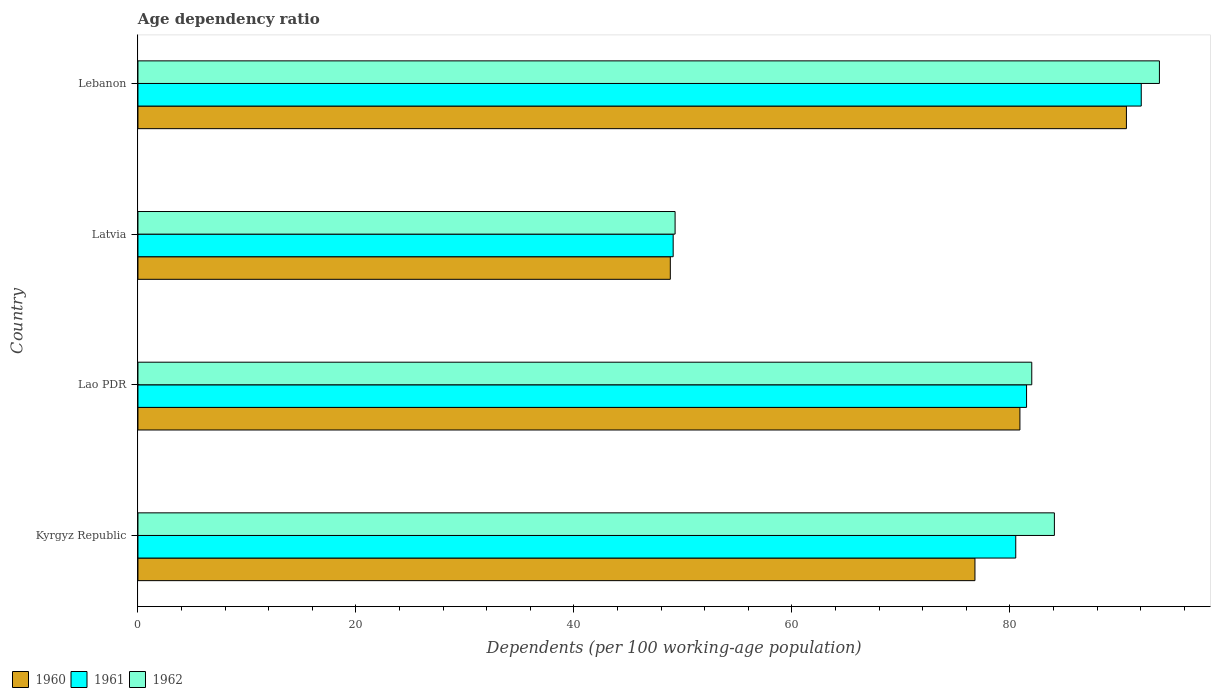How many different coloured bars are there?
Provide a succinct answer. 3. How many groups of bars are there?
Provide a succinct answer. 4. Are the number of bars per tick equal to the number of legend labels?
Your answer should be compact. Yes. Are the number of bars on each tick of the Y-axis equal?
Offer a terse response. Yes. How many bars are there on the 3rd tick from the top?
Ensure brevity in your answer.  3. How many bars are there on the 3rd tick from the bottom?
Ensure brevity in your answer.  3. What is the label of the 4th group of bars from the top?
Make the answer very short. Kyrgyz Republic. In how many cases, is the number of bars for a given country not equal to the number of legend labels?
Give a very brief answer. 0. What is the age dependency ratio in in 1962 in Lebanon?
Provide a succinct answer. 93.73. Across all countries, what is the maximum age dependency ratio in in 1962?
Keep it short and to the point. 93.73. Across all countries, what is the minimum age dependency ratio in in 1961?
Provide a short and direct response. 49.11. In which country was the age dependency ratio in in 1961 maximum?
Provide a short and direct response. Lebanon. In which country was the age dependency ratio in in 1961 minimum?
Provide a short and direct response. Latvia. What is the total age dependency ratio in in 1960 in the graph?
Keep it short and to the point. 297.27. What is the difference between the age dependency ratio in in 1960 in Kyrgyz Republic and that in Lao PDR?
Offer a terse response. -4.13. What is the difference between the age dependency ratio in in 1962 in Lebanon and the age dependency ratio in in 1960 in Kyrgyz Republic?
Offer a very short reply. 16.93. What is the average age dependency ratio in in 1962 per country?
Make the answer very short. 77.28. What is the difference between the age dependency ratio in in 1962 and age dependency ratio in in 1961 in Lao PDR?
Your response must be concise. 0.48. What is the ratio of the age dependency ratio in in 1960 in Kyrgyz Republic to that in Latvia?
Make the answer very short. 1.57. What is the difference between the highest and the second highest age dependency ratio in in 1962?
Keep it short and to the point. 9.64. What is the difference between the highest and the lowest age dependency ratio in in 1961?
Ensure brevity in your answer.  42.95. In how many countries, is the age dependency ratio in in 1960 greater than the average age dependency ratio in in 1960 taken over all countries?
Provide a succinct answer. 3. Is the sum of the age dependency ratio in in 1961 in Lao PDR and Lebanon greater than the maximum age dependency ratio in in 1962 across all countries?
Your answer should be compact. Yes. Is it the case that in every country, the sum of the age dependency ratio in in 1961 and age dependency ratio in in 1960 is greater than the age dependency ratio in in 1962?
Give a very brief answer. Yes. How many bars are there?
Your answer should be very brief. 12. How many countries are there in the graph?
Ensure brevity in your answer.  4. What is the difference between two consecutive major ticks on the X-axis?
Your response must be concise. 20. Are the values on the major ticks of X-axis written in scientific E-notation?
Your answer should be very brief. No. Does the graph contain any zero values?
Give a very brief answer. No. Does the graph contain grids?
Your response must be concise. No. What is the title of the graph?
Give a very brief answer. Age dependency ratio. What is the label or title of the X-axis?
Offer a very short reply. Dependents (per 100 working-age population). What is the Dependents (per 100 working-age population) in 1960 in Kyrgyz Republic?
Offer a terse response. 76.8. What is the Dependents (per 100 working-age population) of 1961 in Kyrgyz Republic?
Your answer should be compact. 80.54. What is the Dependents (per 100 working-age population) in 1962 in Kyrgyz Republic?
Ensure brevity in your answer.  84.09. What is the Dependents (per 100 working-age population) in 1960 in Lao PDR?
Give a very brief answer. 80.93. What is the Dependents (per 100 working-age population) of 1961 in Lao PDR?
Your answer should be very brief. 81.54. What is the Dependents (per 100 working-age population) in 1962 in Lao PDR?
Make the answer very short. 82.01. What is the Dependents (per 100 working-age population) in 1960 in Latvia?
Make the answer very short. 48.85. What is the Dependents (per 100 working-age population) in 1961 in Latvia?
Your response must be concise. 49.11. What is the Dependents (per 100 working-age population) of 1962 in Latvia?
Your answer should be very brief. 49.29. What is the Dependents (per 100 working-age population) in 1960 in Lebanon?
Make the answer very short. 90.7. What is the Dependents (per 100 working-age population) of 1961 in Lebanon?
Provide a succinct answer. 92.06. What is the Dependents (per 100 working-age population) in 1962 in Lebanon?
Your response must be concise. 93.73. Across all countries, what is the maximum Dependents (per 100 working-age population) of 1960?
Make the answer very short. 90.7. Across all countries, what is the maximum Dependents (per 100 working-age population) of 1961?
Keep it short and to the point. 92.06. Across all countries, what is the maximum Dependents (per 100 working-age population) of 1962?
Offer a terse response. 93.73. Across all countries, what is the minimum Dependents (per 100 working-age population) in 1960?
Your answer should be very brief. 48.85. Across all countries, what is the minimum Dependents (per 100 working-age population) in 1961?
Give a very brief answer. 49.11. Across all countries, what is the minimum Dependents (per 100 working-age population) of 1962?
Offer a very short reply. 49.29. What is the total Dependents (per 100 working-age population) of 1960 in the graph?
Give a very brief answer. 297.27. What is the total Dependents (per 100 working-age population) of 1961 in the graph?
Your answer should be compact. 303.25. What is the total Dependents (per 100 working-age population) of 1962 in the graph?
Offer a terse response. 309.12. What is the difference between the Dependents (per 100 working-age population) in 1960 in Kyrgyz Republic and that in Lao PDR?
Make the answer very short. -4.13. What is the difference between the Dependents (per 100 working-age population) of 1961 in Kyrgyz Republic and that in Lao PDR?
Keep it short and to the point. -0.99. What is the difference between the Dependents (per 100 working-age population) in 1962 in Kyrgyz Republic and that in Lao PDR?
Your answer should be compact. 2.08. What is the difference between the Dependents (per 100 working-age population) of 1960 in Kyrgyz Republic and that in Latvia?
Give a very brief answer. 27.95. What is the difference between the Dependents (per 100 working-age population) in 1961 in Kyrgyz Republic and that in Latvia?
Ensure brevity in your answer.  31.43. What is the difference between the Dependents (per 100 working-age population) of 1962 in Kyrgyz Republic and that in Latvia?
Ensure brevity in your answer.  34.8. What is the difference between the Dependents (per 100 working-age population) in 1960 in Kyrgyz Republic and that in Lebanon?
Ensure brevity in your answer.  -13.9. What is the difference between the Dependents (per 100 working-age population) in 1961 in Kyrgyz Republic and that in Lebanon?
Offer a terse response. -11.52. What is the difference between the Dependents (per 100 working-age population) in 1962 in Kyrgyz Republic and that in Lebanon?
Provide a short and direct response. -9.64. What is the difference between the Dependents (per 100 working-age population) in 1960 in Lao PDR and that in Latvia?
Offer a terse response. 32.08. What is the difference between the Dependents (per 100 working-age population) of 1961 in Lao PDR and that in Latvia?
Make the answer very short. 32.43. What is the difference between the Dependents (per 100 working-age population) in 1962 in Lao PDR and that in Latvia?
Provide a succinct answer. 32.73. What is the difference between the Dependents (per 100 working-age population) in 1960 in Lao PDR and that in Lebanon?
Make the answer very short. -9.77. What is the difference between the Dependents (per 100 working-age population) of 1961 in Lao PDR and that in Lebanon?
Provide a succinct answer. -10.52. What is the difference between the Dependents (per 100 working-age population) of 1962 in Lao PDR and that in Lebanon?
Ensure brevity in your answer.  -11.71. What is the difference between the Dependents (per 100 working-age population) of 1960 in Latvia and that in Lebanon?
Your response must be concise. -41.85. What is the difference between the Dependents (per 100 working-age population) of 1961 in Latvia and that in Lebanon?
Your response must be concise. -42.95. What is the difference between the Dependents (per 100 working-age population) of 1962 in Latvia and that in Lebanon?
Provide a short and direct response. -44.44. What is the difference between the Dependents (per 100 working-age population) of 1960 in Kyrgyz Republic and the Dependents (per 100 working-age population) of 1961 in Lao PDR?
Provide a short and direct response. -4.74. What is the difference between the Dependents (per 100 working-age population) of 1960 in Kyrgyz Republic and the Dependents (per 100 working-age population) of 1962 in Lao PDR?
Ensure brevity in your answer.  -5.21. What is the difference between the Dependents (per 100 working-age population) of 1961 in Kyrgyz Republic and the Dependents (per 100 working-age population) of 1962 in Lao PDR?
Ensure brevity in your answer.  -1.47. What is the difference between the Dependents (per 100 working-age population) of 1960 in Kyrgyz Republic and the Dependents (per 100 working-age population) of 1961 in Latvia?
Your answer should be compact. 27.69. What is the difference between the Dependents (per 100 working-age population) of 1960 in Kyrgyz Republic and the Dependents (per 100 working-age population) of 1962 in Latvia?
Offer a very short reply. 27.51. What is the difference between the Dependents (per 100 working-age population) in 1961 in Kyrgyz Republic and the Dependents (per 100 working-age population) in 1962 in Latvia?
Ensure brevity in your answer.  31.26. What is the difference between the Dependents (per 100 working-age population) in 1960 in Kyrgyz Republic and the Dependents (per 100 working-age population) in 1961 in Lebanon?
Your answer should be compact. -15.26. What is the difference between the Dependents (per 100 working-age population) of 1960 in Kyrgyz Republic and the Dependents (per 100 working-age population) of 1962 in Lebanon?
Keep it short and to the point. -16.93. What is the difference between the Dependents (per 100 working-age population) in 1961 in Kyrgyz Republic and the Dependents (per 100 working-age population) in 1962 in Lebanon?
Give a very brief answer. -13.18. What is the difference between the Dependents (per 100 working-age population) in 1960 in Lao PDR and the Dependents (per 100 working-age population) in 1961 in Latvia?
Your response must be concise. 31.82. What is the difference between the Dependents (per 100 working-age population) of 1960 in Lao PDR and the Dependents (per 100 working-age population) of 1962 in Latvia?
Keep it short and to the point. 31.64. What is the difference between the Dependents (per 100 working-age population) in 1961 in Lao PDR and the Dependents (per 100 working-age population) in 1962 in Latvia?
Provide a short and direct response. 32.25. What is the difference between the Dependents (per 100 working-age population) in 1960 in Lao PDR and the Dependents (per 100 working-age population) in 1961 in Lebanon?
Provide a short and direct response. -11.13. What is the difference between the Dependents (per 100 working-age population) of 1961 in Lao PDR and the Dependents (per 100 working-age population) of 1962 in Lebanon?
Offer a terse response. -12.19. What is the difference between the Dependents (per 100 working-age population) of 1960 in Latvia and the Dependents (per 100 working-age population) of 1961 in Lebanon?
Offer a terse response. -43.21. What is the difference between the Dependents (per 100 working-age population) of 1960 in Latvia and the Dependents (per 100 working-age population) of 1962 in Lebanon?
Your answer should be compact. -44.88. What is the difference between the Dependents (per 100 working-age population) of 1961 in Latvia and the Dependents (per 100 working-age population) of 1962 in Lebanon?
Give a very brief answer. -44.62. What is the average Dependents (per 100 working-age population) of 1960 per country?
Provide a succinct answer. 74.32. What is the average Dependents (per 100 working-age population) in 1961 per country?
Your answer should be compact. 75.81. What is the average Dependents (per 100 working-age population) in 1962 per country?
Your response must be concise. 77.28. What is the difference between the Dependents (per 100 working-age population) in 1960 and Dependents (per 100 working-age population) in 1961 in Kyrgyz Republic?
Ensure brevity in your answer.  -3.74. What is the difference between the Dependents (per 100 working-age population) in 1960 and Dependents (per 100 working-age population) in 1962 in Kyrgyz Republic?
Your response must be concise. -7.29. What is the difference between the Dependents (per 100 working-age population) in 1961 and Dependents (per 100 working-age population) in 1962 in Kyrgyz Republic?
Provide a succinct answer. -3.55. What is the difference between the Dependents (per 100 working-age population) in 1960 and Dependents (per 100 working-age population) in 1961 in Lao PDR?
Provide a short and direct response. -0.61. What is the difference between the Dependents (per 100 working-age population) of 1960 and Dependents (per 100 working-age population) of 1962 in Lao PDR?
Your answer should be very brief. -1.09. What is the difference between the Dependents (per 100 working-age population) in 1961 and Dependents (per 100 working-age population) in 1962 in Lao PDR?
Offer a very short reply. -0.48. What is the difference between the Dependents (per 100 working-age population) of 1960 and Dependents (per 100 working-age population) of 1961 in Latvia?
Offer a very short reply. -0.26. What is the difference between the Dependents (per 100 working-age population) of 1960 and Dependents (per 100 working-age population) of 1962 in Latvia?
Your answer should be very brief. -0.44. What is the difference between the Dependents (per 100 working-age population) in 1961 and Dependents (per 100 working-age population) in 1962 in Latvia?
Keep it short and to the point. -0.18. What is the difference between the Dependents (per 100 working-age population) of 1960 and Dependents (per 100 working-age population) of 1961 in Lebanon?
Offer a terse response. -1.36. What is the difference between the Dependents (per 100 working-age population) in 1960 and Dependents (per 100 working-age population) in 1962 in Lebanon?
Keep it short and to the point. -3.03. What is the difference between the Dependents (per 100 working-age population) in 1961 and Dependents (per 100 working-age population) in 1962 in Lebanon?
Provide a succinct answer. -1.67. What is the ratio of the Dependents (per 100 working-age population) in 1960 in Kyrgyz Republic to that in Lao PDR?
Give a very brief answer. 0.95. What is the ratio of the Dependents (per 100 working-age population) of 1962 in Kyrgyz Republic to that in Lao PDR?
Give a very brief answer. 1.03. What is the ratio of the Dependents (per 100 working-age population) of 1960 in Kyrgyz Republic to that in Latvia?
Make the answer very short. 1.57. What is the ratio of the Dependents (per 100 working-age population) in 1961 in Kyrgyz Republic to that in Latvia?
Provide a succinct answer. 1.64. What is the ratio of the Dependents (per 100 working-age population) in 1962 in Kyrgyz Republic to that in Latvia?
Ensure brevity in your answer.  1.71. What is the ratio of the Dependents (per 100 working-age population) of 1960 in Kyrgyz Republic to that in Lebanon?
Offer a terse response. 0.85. What is the ratio of the Dependents (per 100 working-age population) of 1961 in Kyrgyz Republic to that in Lebanon?
Ensure brevity in your answer.  0.87. What is the ratio of the Dependents (per 100 working-age population) of 1962 in Kyrgyz Republic to that in Lebanon?
Offer a very short reply. 0.9. What is the ratio of the Dependents (per 100 working-age population) in 1960 in Lao PDR to that in Latvia?
Provide a short and direct response. 1.66. What is the ratio of the Dependents (per 100 working-age population) in 1961 in Lao PDR to that in Latvia?
Give a very brief answer. 1.66. What is the ratio of the Dependents (per 100 working-age population) in 1962 in Lao PDR to that in Latvia?
Your response must be concise. 1.66. What is the ratio of the Dependents (per 100 working-age population) of 1960 in Lao PDR to that in Lebanon?
Offer a terse response. 0.89. What is the ratio of the Dependents (per 100 working-age population) of 1961 in Lao PDR to that in Lebanon?
Give a very brief answer. 0.89. What is the ratio of the Dependents (per 100 working-age population) of 1960 in Latvia to that in Lebanon?
Your answer should be compact. 0.54. What is the ratio of the Dependents (per 100 working-age population) in 1961 in Latvia to that in Lebanon?
Make the answer very short. 0.53. What is the ratio of the Dependents (per 100 working-age population) in 1962 in Latvia to that in Lebanon?
Provide a succinct answer. 0.53. What is the difference between the highest and the second highest Dependents (per 100 working-age population) in 1960?
Your response must be concise. 9.77. What is the difference between the highest and the second highest Dependents (per 100 working-age population) of 1961?
Your answer should be compact. 10.52. What is the difference between the highest and the second highest Dependents (per 100 working-age population) in 1962?
Offer a very short reply. 9.64. What is the difference between the highest and the lowest Dependents (per 100 working-age population) in 1960?
Ensure brevity in your answer.  41.85. What is the difference between the highest and the lowest Dependents (per 100 working-age population) in 1961?
Provide a short and direct response. 42.95. What is the difference between the highest and the lowest Dependents (per 100 working-age population) in 1962?
Ensure brevity in your answer.  44.44. 